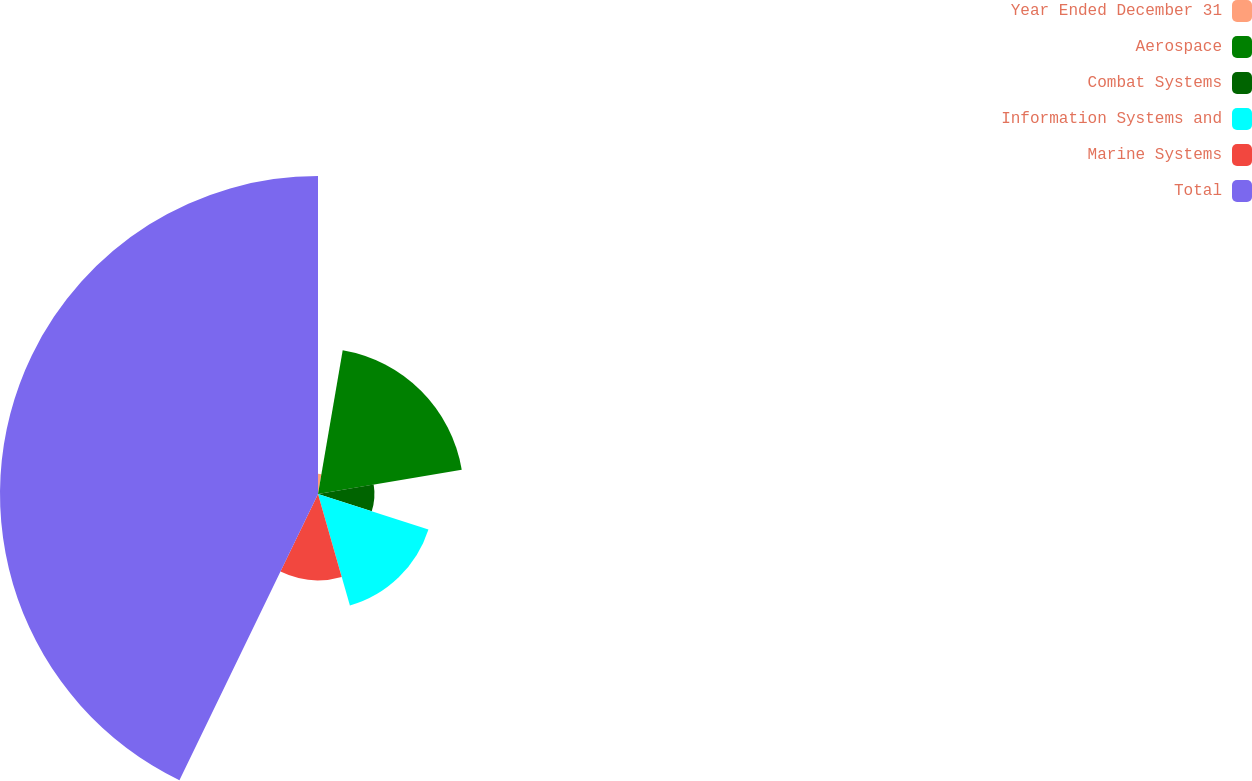Convert chart to OTSL. <chart><loc_0><loc_0><loc_500><loc_500><pie_chart><fcel>Year Ended December 31<fcel>Aerospace<fcel>Combat Systems<fcel>Information Systems and<fcel>Marine Systems<fcel>Total<nl><fcel>2.71%<fcel>19.63%<fcel>7.6%<fcel>15.62%<fcel>11.61%<fcel>42.82%<nl></chart> 